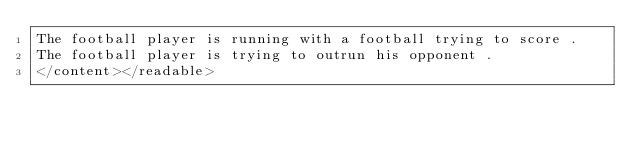<code> <loc_0><loc_0><loc_500><loc_500><_XML_>The football player is running with a football trying to score .
The football player is trying to outrun his opponent .
</content></readable></code> 